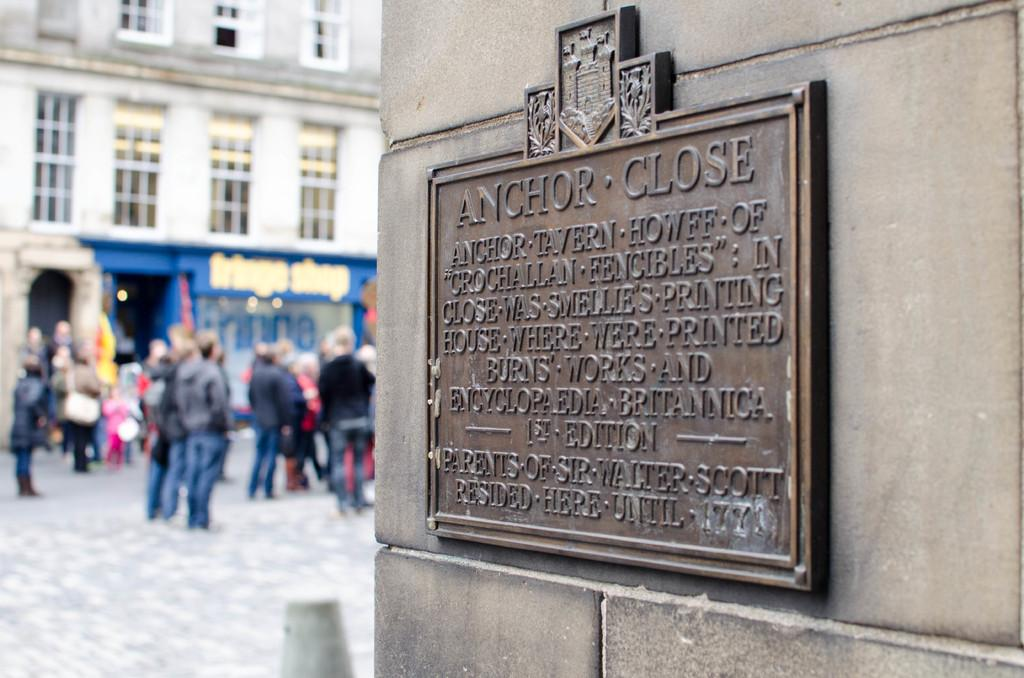What is the main subject of the image? The main subject of the image is the persons standing on the ground. What can be seen in the background of the image? There are buildings around them in the background. What is the object with text on it? There is a frame with text on it. Where is the frame with text located? The frame is placed on a wall. What type of string is being used to hold the reward in the image? There is no string or reward present in the image. What is the table used for in the image? There is no table present in the image. 